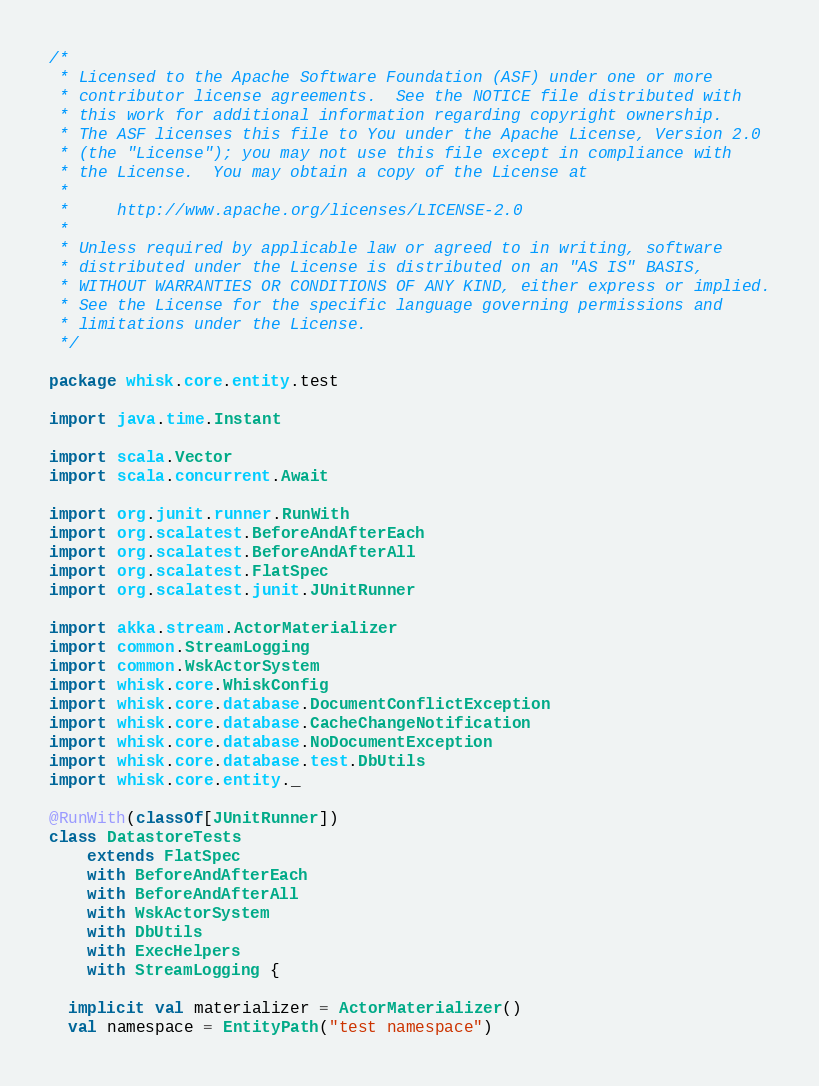Convert code to text. <code><loc_0><loc_0><loc_500><loc_500><_Scala_>/*
 * Licensed to the Apache Software Foundation (ASF) under one or more
 * contributor license agreements.  See the NOTICE file distributed with
 * this work for additional information regarding copyright ownership.
 * The ASF licenses this file to You under the Apache License, Version 2.0
 * (the "License"); you may not use this file except in compliance with
 * the License.  You may obtain a copy of the License at
 *
 *     http://www.apache.org/licenses/LICENSE-2.0
 *
 * Unless required by applicable law or agreed to in writing, software
 * distributed under the License is distributed on an "AS IS" BASIS,
 * WITHOUT WARRANTIES OR CONDITIONS OF ANY KIND, either express or implied.
 * See the License for the specific language governing permissions and
 * limitations under the License.
 */

package whisk.core.entity.test

import java.time.Instant

import scala.Vector
import scala.concurrent.Await

import org.junit.runner.RunWith
import org.scalatest.BeforeAndAfterEach
import org.scalatest.BeforeAndAfterAll
import org.scalatest.FlatSpec
import org.scalatest.junit.JUnitRunner

import akka.stream.ActorMaterializer
import common.StreamLogging
import common.WskActorSystem
import whisk.core.WhiskConfig
import whisk.core.database.DocumentConflictException
import whisk.core.database.CacheChangeNotification
import whisk.core.database.NoDocumentException
import whisk.core.database.test.DbUtils
import whisk.core.entity._

@RunWith(classOf[JUnitRunner])
class DatastoreTests
    extends FlatSpec
    with BeforeAndAfterEach
    with BeforeAndAfterAll
    with WskActorSystem
    with DbUtils
    with ExecHelpers
    with StreamLogging {

  implicit val materializer = ActorMaterializer()
  val namespace = EntityPath("test namespace")</code> 